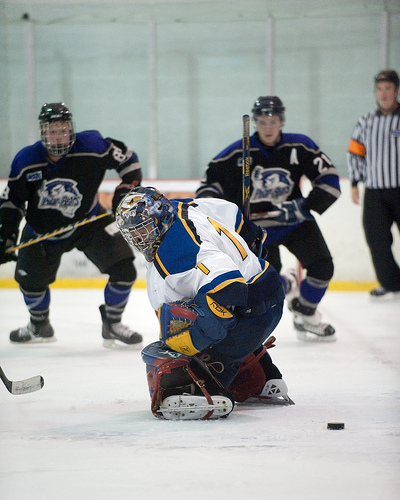<image>
Can you confirm if the helmet is on the man? Yes. Looking at the image, I can see the helmet is positioned on top of the man, with the man providing support. 